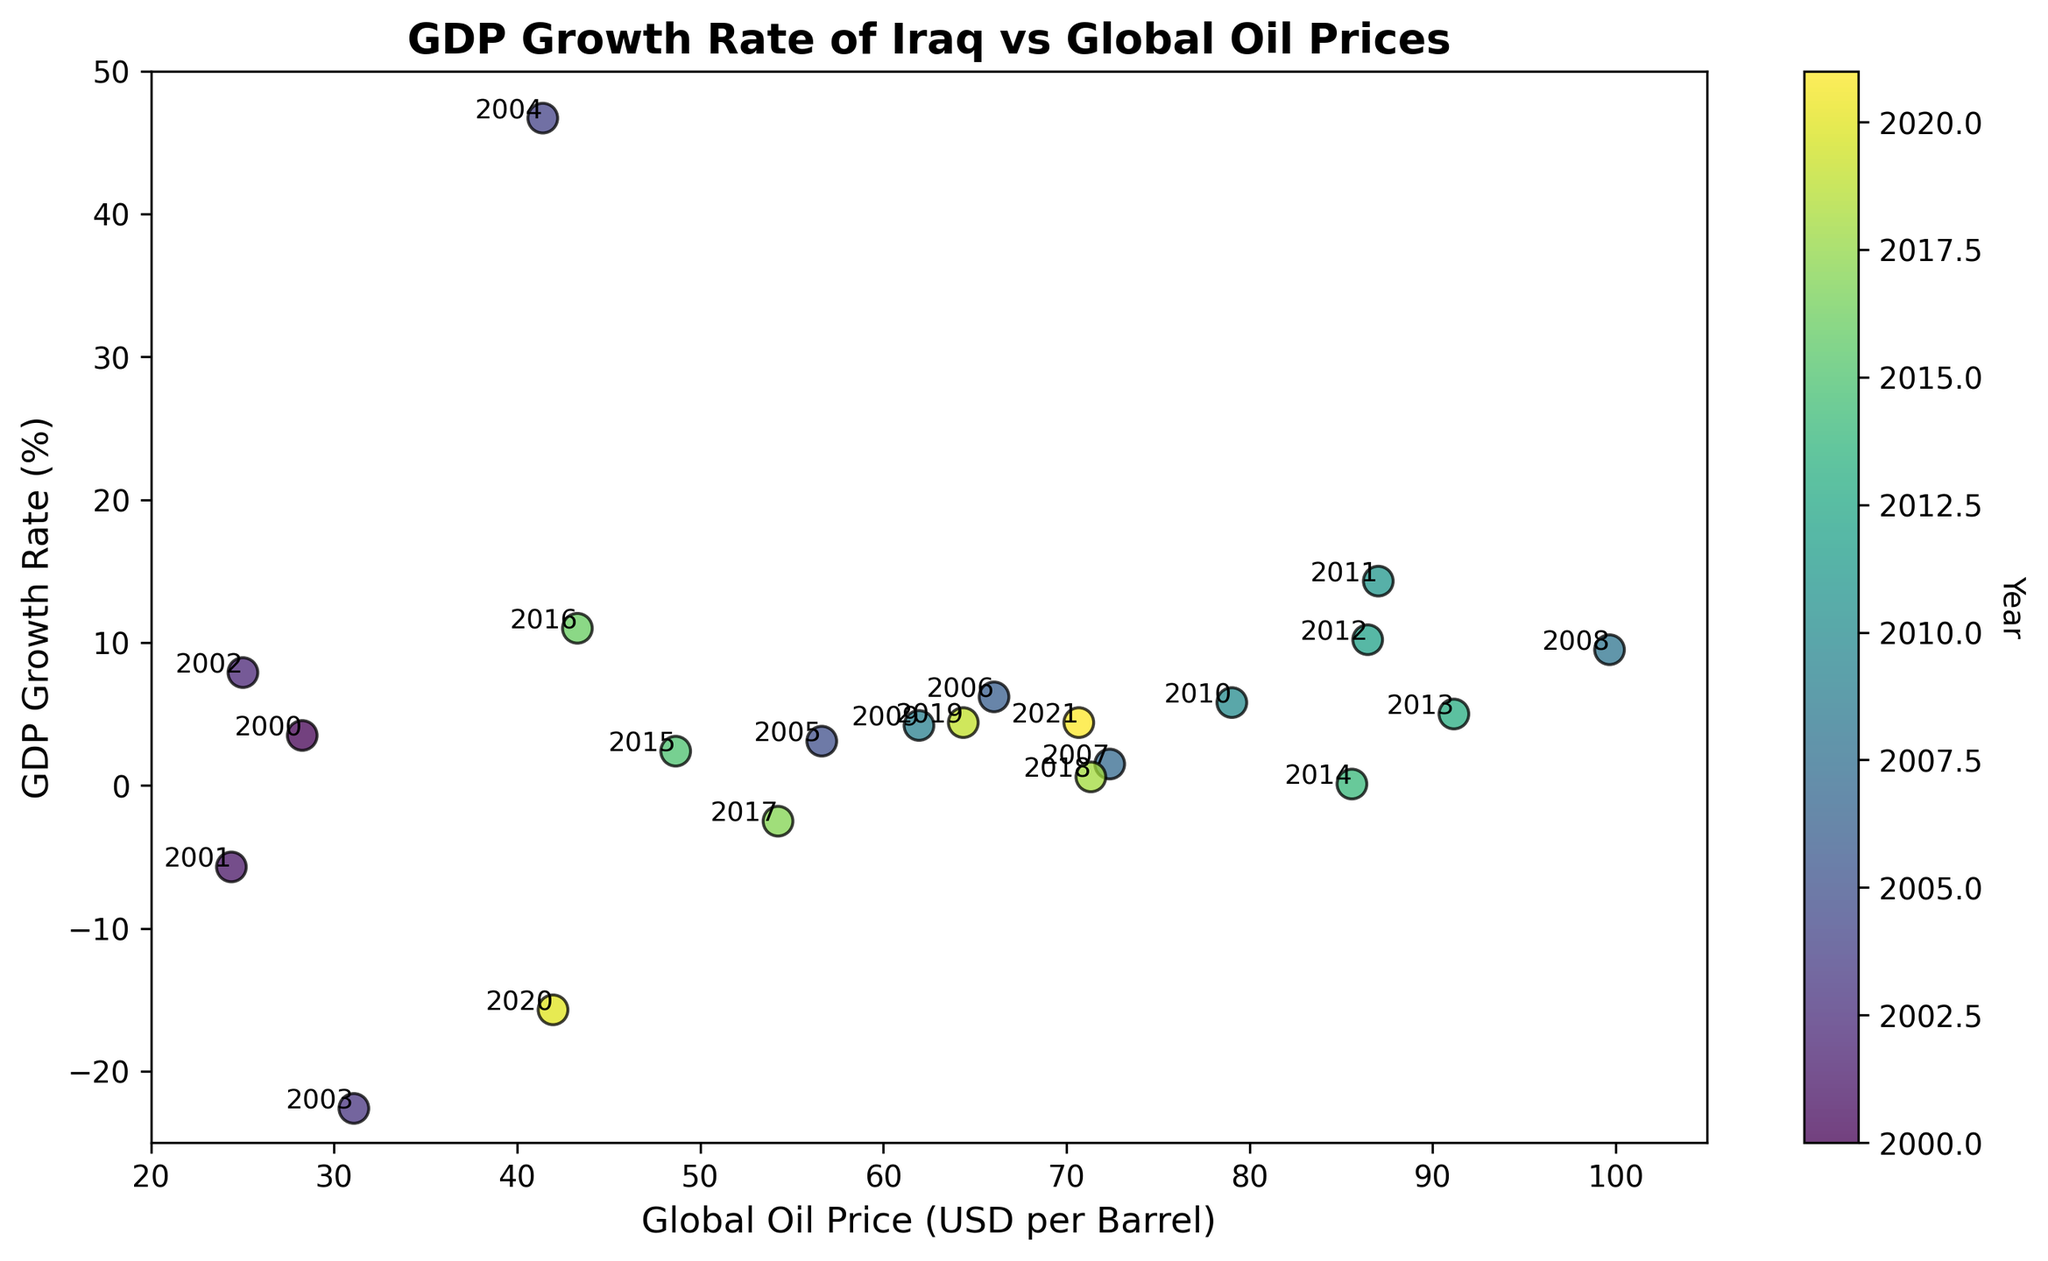What year had the highest GDP growth rate? From the figure, find the data point with the highest y-coordinate, which represents GDP growth rate. The highest rate is at 46.7%, and the associated year is 2004.
Answer: 2004 What is the general trend between oil prices and GDP growth in Iraq? Observe the overall pattern in the scatter plot points. Notice if higher oil prices correspond to higher or lower GDP growth rates. Generally, higher oil prices tend to correspond to higher GDP growth rates, although there are exceptions.
Answer: Higher prices, higher growth (with exceptions) Which year experienced the lowest GDP growth rate? From the figure, identify the data point with the lowest y-coordinate, representing the GDP growth rate. The lowest value is -22.6%, and the associated year is 2003.
Answer: 2003 Which year had both a moderately high oil price and a moderately high GDP growth rate? Find a point in the middle-to-upper range of both the x-axis (oil price) and y-axis (GDP growth). The year 2016 has moderate-high oil price around 43.29 and a GDP growth rate of 11.0%.
Answer: 2016 Compare the GDP growth rate of Iraq in 2014 with its rate in 2018. Which year had a higher rate? Identify the y-coordinates corresponding to 2014 and 2018 on the scatter plot. 2014 had a rate of 0.1%, whereas 2018 had a rate of 0.6%.
Answer: 2018 During which years did Iraq experience negative GDP growth rates? Look for points below the y-axis where the GDP growth rate is negative. The years are 2001, 2003, 2017, and 2020.
Answer: 2001, 2003, 2017, 2020 What was the approximate oil price in the global market in 2005? Find the label "2005" on the plot and identify the corresponding x-coordinate, which represents the oil price. The oil price in 2005 was approximately 56.64 USD per barrel.
Answer: 56.64 USD Which year had the highest oil price, and what was the GDP growth rate that year? Locate the highest x-coordinate (oil price) on the plot, which is 99.67 USD in 2008. The corresponding y-coordinate, or GDP growth rate, for that year is 9.5%.
Answer: 2008, 9.5% Is there a year where both oil price and GDP growth rate were close to zero? Scan for a point near the intersection of the x-axis and y-axis. The closest to zero for both is in 2014 with an oil price of 85.60 and GDP growth rate of 0.1%.
Answer: 2014 